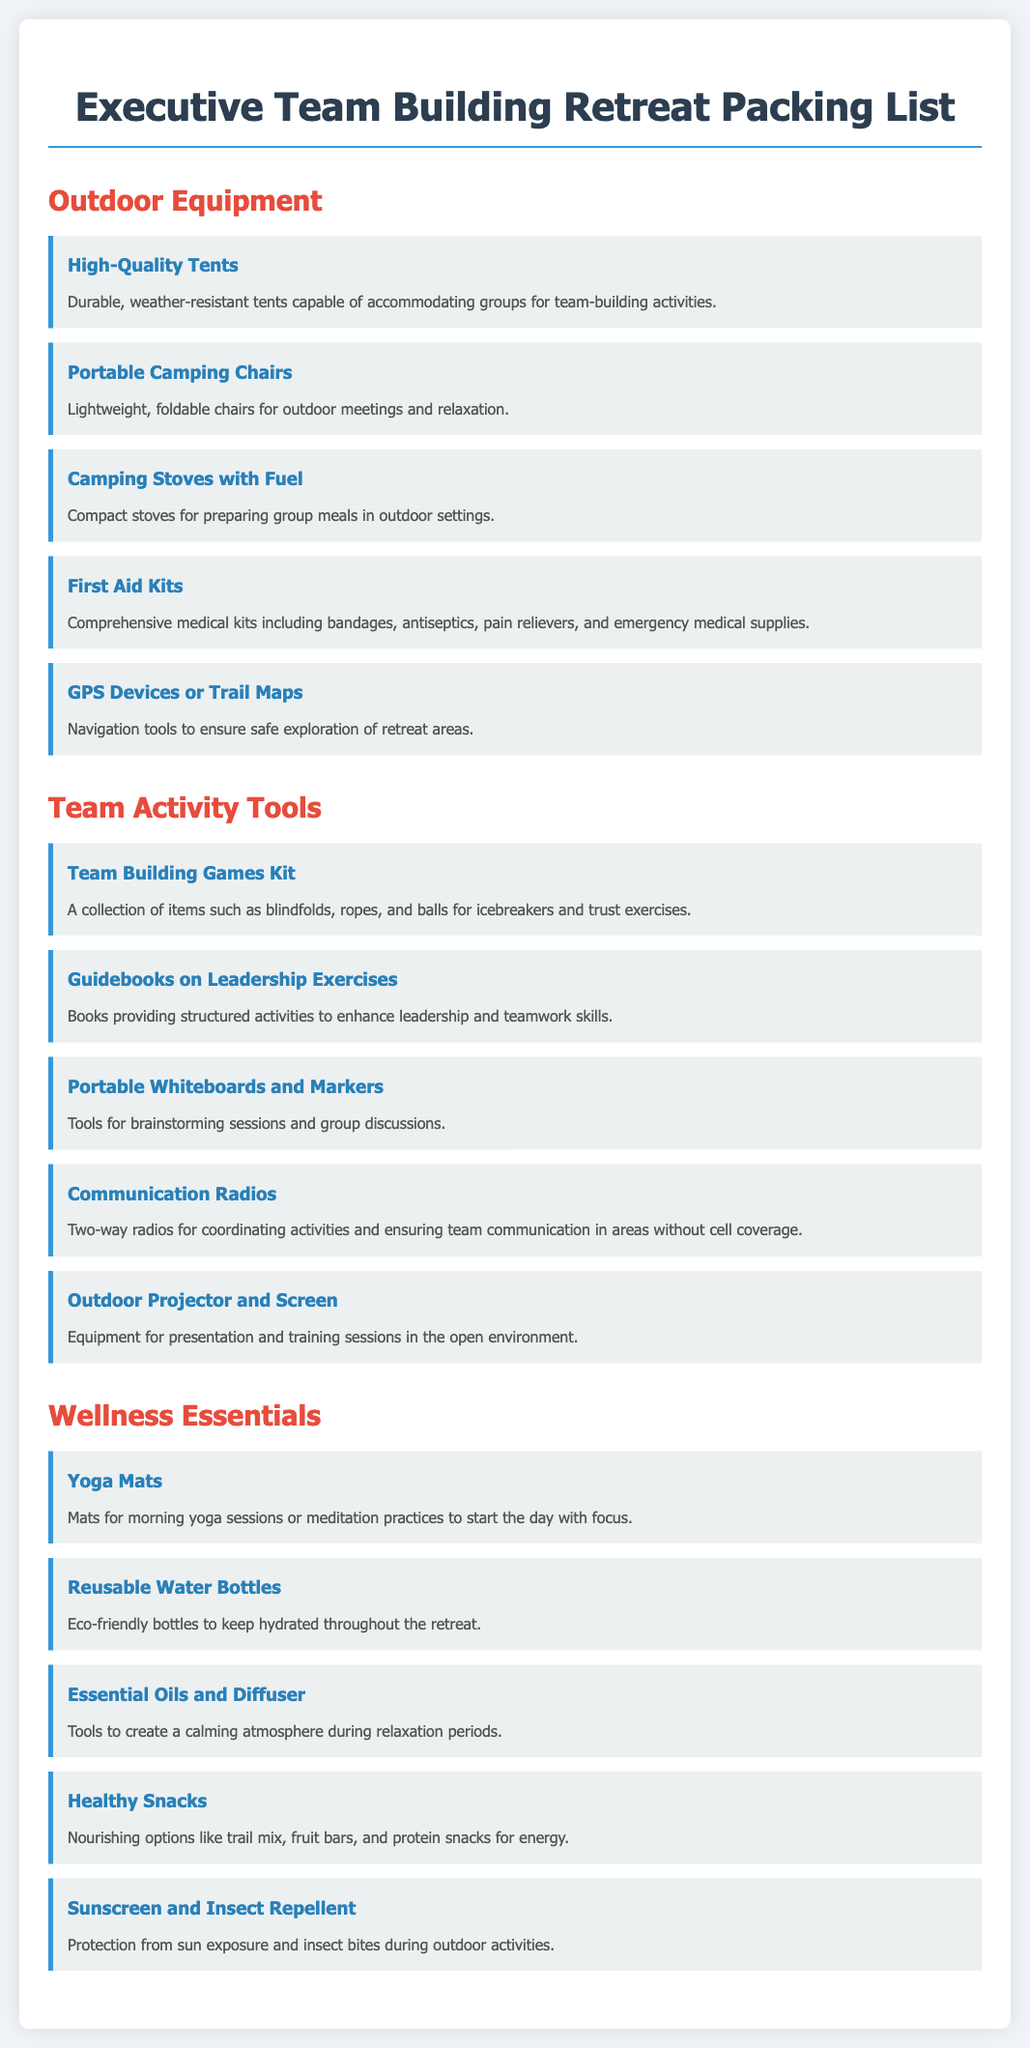what is the title of the document? The title of the document is provided in the header section and states the purpose of the list.
Answer: Executive Team Building Retreat Packing List how many outdoor equipment items are listed? The number of items listed under the outdoor equipment section is counted from the document.
Answer: 5 what is one item included in the team activity tools? The document contains several items under team activity tools, and one can be referenced as an example.
Answer: Team Building Games Kit what do yoga mats contribute to in the retreat? The role of yoga mats is indicated in the wellness essentials section to explain their purpose during the retreat.
Answer: morning yoga sessions what is the purpose of communication radios? The document describes the communication radios’ function in ensuring effective teamwork.
Answer: coordinating activities which item is recommended for hydration? The wellness essentials section mentions an item that helps maintain hydration during the retreat.
Answer: Reusable Water Bottles how many wellness essentials are listed? The total count of items under the wellness essentials section provides insight into what is suggested for well-being.
Answer: 5 what type of kits are mentioned for first aid? The specific nature and content of the kits in the outdoor equipment section clarify their purpose.
Answer: Comprehensive medical kits 